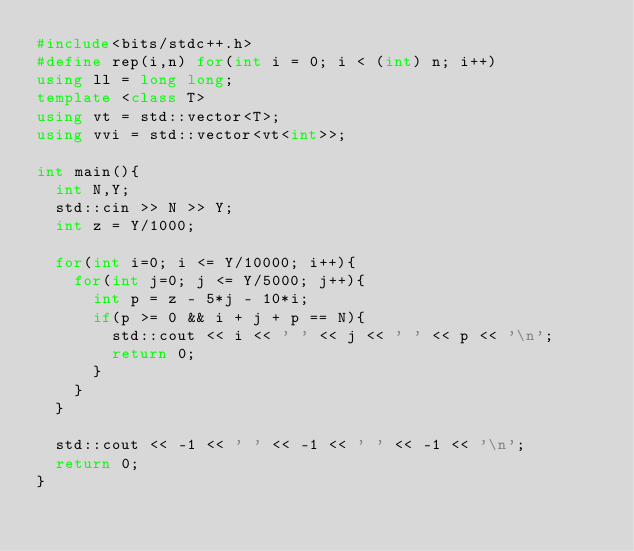<code> <loc_0><loc_0><loc_500><loc_500><_C++_>#include<bits/stdc++.h>
#define rep(i,n) for(int i = 0; i < (int) n; i++)
using ll = long long;
template <class T>
using vt = std::vector<T>;
using vvi = std::vector<vt<int>>;

int main(){
  int N,Y;
  std::cin >> N >> Y;
  int z = Y/1000;

  for(int i=0; i <= Y/10000; i++){
    for(int j=0; j <= Y/5000; j++){
      int p = z - 5*j - 10*i;
      if(p >= 0 && i + j + p == N){
        std::cout << i << ' ' << j << ' ' << p << '\n';
        return 0;
      }
    }
  }

  std::cout << -1 << ' ' << -1 << ' ' << -1 << '\n';
  return 0;
}
</code> 